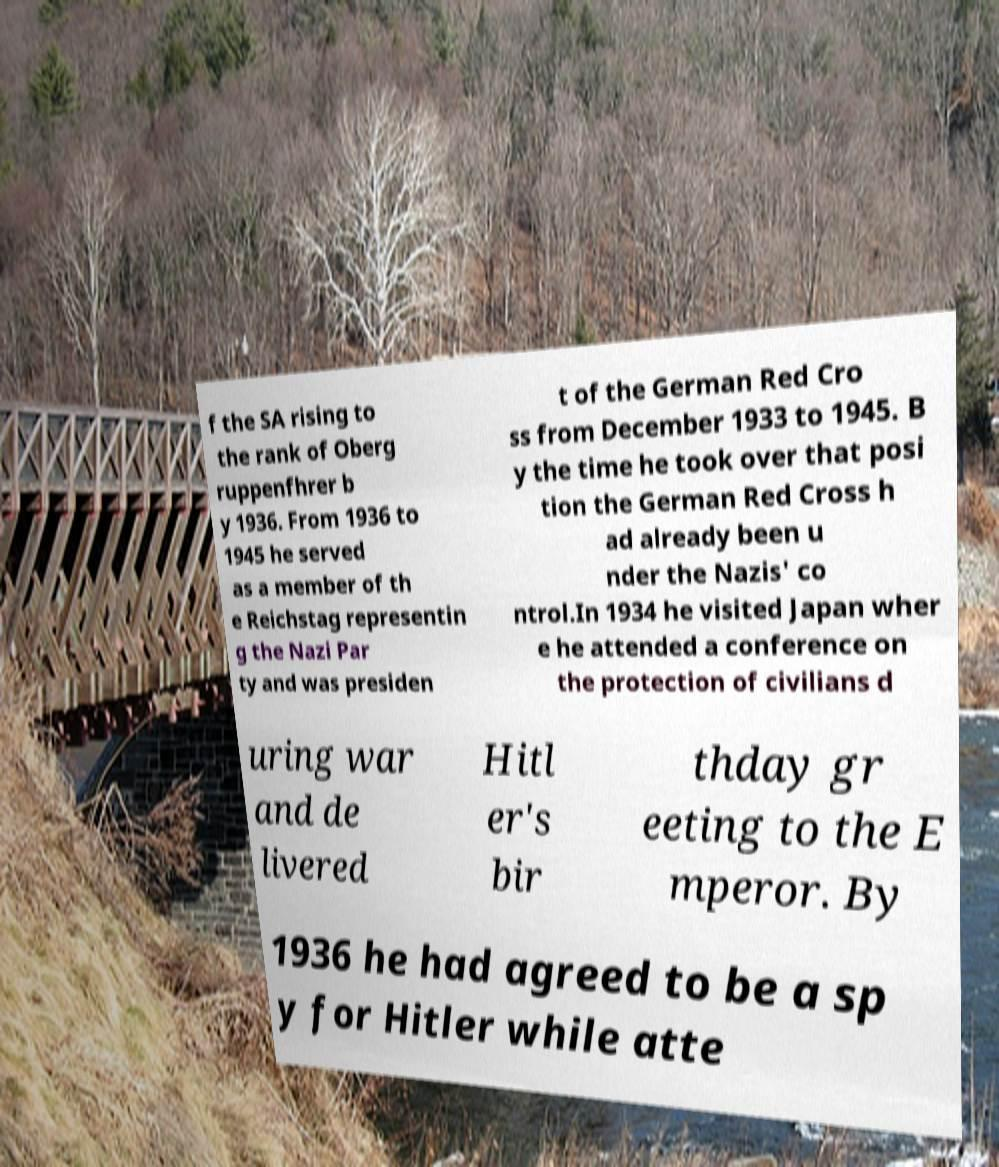Can you read and provide the text displayed in the image?This photo seems to have some interesting text. Can you extract and type it out for me? f the SA rising to the rank of Oberg ruppenfhrer b y 1936. From 1936 to 1945 he served as a member of th e Reichstag representin g the Nazi Par ty and was presiden t of the German Red Cro ss from December 1933 to 1945. B y the time he took over that posi tion the German Red Cross h ad already been u nder the Nazis' co ntrol.In 1934 he visited Japan wher e he attended a conference on the protection of civilians d uring war and de livered Hitl er's bir thday gr eeting to the E mperor. By 1936 he had agreed to be a sp y for Hitler while atte 